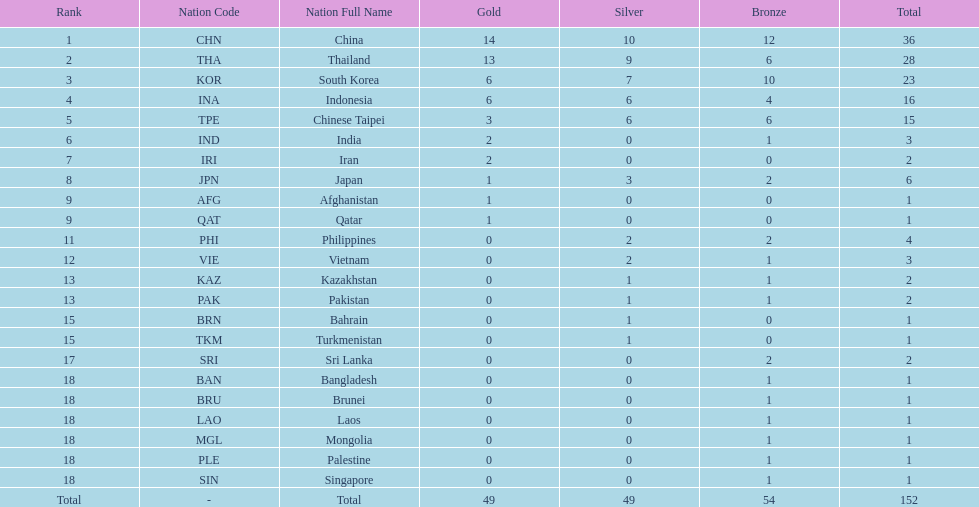How many combined silver medals did china, india, and japan earn ? 13. 